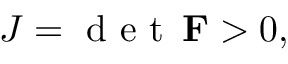<formula> <loc_0><loc_0><loc_500><loc_500>J = d e t \, F > 0 ,</formula> 